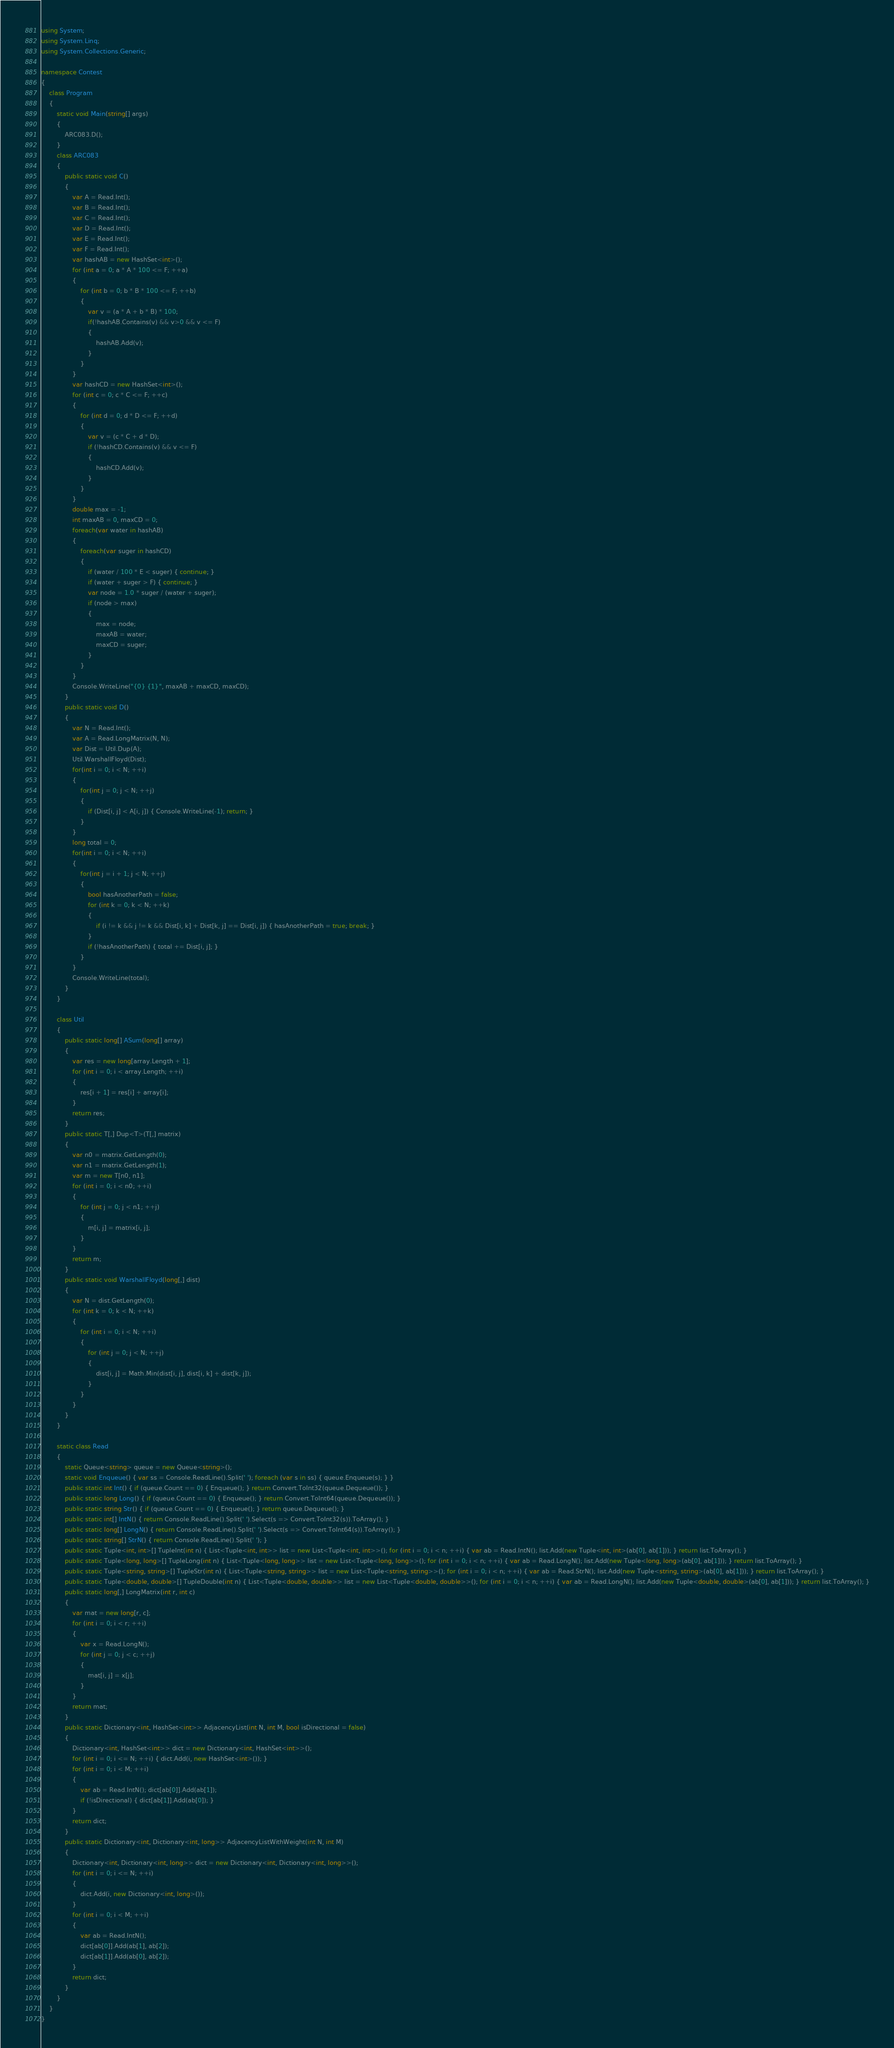Convert code to text. <code><loc_0><loc_0><loc_500><loc_500><_C#_>using System;
using System.Linq;
using System.Collections.Generic;

namespace Contest
{
    class Program
    {
        static void Main(string[] args)
        {
            ARC083.D();
        }
        class ARC083
        {
            public static void C()
            {
                var A = Read.Int();
                var B = Read.Int();
                var C = Read.Int();
                var D = Read.Int();
                var E = Read.Int();
                var F = Read.Int();
                var hashAB = new HashSet<int>();
                for (int a = 0; a * A * 100 <= F; ++a)
                {
                    for (int b = 0; b * B * 100 <= F; ++b)
                    {
                        var v = (a * A + b * B) * 100;
                        if(!hashAB.Contains(v) && v>0 && v <= F)
                        {
                            hashAB.Add(v);
                        }
                    }
                }
                var hashCD = new HashSet<int>();
                for (int c = 0; c * C <= F; ++c)
                {
                    for (int d = 0; d * D <= F; ++d)
                    {
                        var v = (c * C + d * D);
                        if (!hashCD.Contains(v) && v <= F)
                        {
                            hashCD.Add(v);
                        }
                    }
                }
                double max = -1;
                int maxAB = 0, maxCD = 0;
                foreach(var water in hashAB)
                {
                    foreach(var suger in hashCD)
                    {
                        if (water / 100 * E < suger) { continue; }
                        if (water + suger > F) { continue; }
                        var node = 1.0 * suger / (water + suger);
                        if (node > max)
                        {
                            max = node;
                            maxAB = water;
                            maxCD = suger;
                        }
                    }
                }
                Console.WriteLine("{0} {1}", maxAB + maxCD, maxCD);
            }
            public static void D()
            {
                var N = Read.Int();
                var A = Read.LongMatrix(N, N);
                var Dist = Util.Dup(A);
                Util.WarshallFloyd(Dist);
                for(int i = 0; i < N; ++i)
                {
                    for(int j = 0; j < N; ++j)
                    {
                        if (Dist[i, j] < A[i, j]) { Console.WriteLine(-1); return; }
                    }
                }
                long total = 0;
                for(int i = 0; i < N; ++i)
                {
                    for(int j = i + 1; j < N; ++j)
                    {
                        bool hasAnotherPath = false;
                        for (int k = 0; k < N; ++k)
                        {
                            if (i != k && j != k && Dist[i, k] + Dist[k, j] == Dist[i, j]) { hasAnotherPath = true; break; }
                        }
                        if (!hasAnotherPath) { total += Dist[i, j]; }
                    }
                }
                Console.WriteLine(total);
            }
        }

        class Util
        {
            public static long[] ASum(long[] array)
            {
                var res = new long[array.Length + 1];
                for (int i = 0; i < array.Length; ++i)
                {
                    res[i + 1] = res[i] + array[i];
                }
                return res;
            }
            public static T[,] Dup<T>(T[,] matrix)
            {
                var n0 = matrix.GetLength(0);
                var n1 = matrix.GetLength(1);
                var m = new T[n0, n1];
                for (int i = 0; i < n0; ++i)
                {
                    for (int j = 0; j < n1; ++j)
                    {
                        m[i, j] = matrix[i, j];
                    }
                }
                return m;
            }
            public static void WarshallFloyd(long[,] dist)
            {
                var N = dist.GetLength(0);
                for (int k = 0; k < N; ++k)
                {
                    for (int i = 0; i < N; ++i)
                    {
                        for (int j = 0; j < N; ++j)
                        {
                            dist[i, j] = Math.Min(dist[i, j], dist[i, k] + dist[k, j]);
                        }
                    }
                }
            }
        }

        static class Read
        {
            static Queue<string> queue = new Queue<string>();
            static void Enqueue() { var ss = Console.ReadLine().Split(' '); foreach (var s in ss) { queue.Enqueue(s); } }
            public static int Int() { if (queue.Count == 0) { Enqueue(); } return Convert.ToInt32(queue.Dequeue()); }
            public static long Long() { if (queue.Count == 0) { Enqueue(); } return Convert.ToInt64(queue.Dequeue()); }
            public static string Str() { if (queue.Count == 0) { Enqueue(); } return queue.Dequeue(); }
            public static int[] IntN() { return Console.ReadLine().Split(' ').Select(s => Convert.ToInt32(s)).ToArray(); }
            public static long[] LongN() { return Console.ReadLine().Split(' ').Select(s => Convert.ToInt64(s)).ToArray(); }
            public static string[] StrN() { return Console.ReadLine().Split(' '); }
            public static Tuple<int, int>[] TupleInt(int n) { List<Tuple<int, int>> list = new List<Tuple<int, int>>(); for (int i = 0; i < n; ++i) { var ab = Read.IntN(); list.Add(new Tuple<int, int>(ab[0], ab[1])); } return list.ToArray(); }
            public static Tuple<long, long>[] TupleLong(int n) { List<Tuple<long, long>> list = new List<Tuple<long, long>>(); for (int i = 0; i < n; ++i) { var ab = Read.LongN(); list.Add(new Tuple<long, long>(ab[0], ab[1])); } return list.ToArray(); }
            public static Tuple<string, string>[] TupleStr(int n) { List<Tuple<string, string>> list = new List<Tuple<string, string>>(); for (int i = 0; i < n; ++i) { var ab = Read.StrN(); list.Add(new Tuple<string, string>(ab[0], ab[1])); } return list.ToArray(); }
            public static Tuple<double, double>[] TupleDouble(int n) { List<Tuple<double, double>> list = new List<Tuple<double, double>>(); for (int i = 0; i < n; ++i) { var ab = Read.LongN(); list.Add(new Tuple<double, double>(ab[0], ab[1])); } return list.ToArray(); }
            public static long[,] LongMatrix(int r, int c)
            {
                var mat = new long[r, c];
                for (int i = 0; i < r; ++i)
                {
                    var x = Read.LongN();
                    for (int j = 0; j < c; ++j)
                    {
                        mat[i, j] = x[j];
                    }
                }
                return mat;
            }
            public static Dictionary<int, HashSet<int>> AdjacencyList(int N, int M, bool isDirectional = false)
            {
                Dictionary<int, HashSet<int>> dict = new Dictionary<int, HashSet<int>>();
                for (int i = 0; i <= N; ++i) { dict.Add(i, new HashSet<int>()); }
                for (int i = 0; i < M; ++i)
                {
                    var ab = Read.IntN(); dict[ab[0]].Add(ab[1]);
                    if (!isDirectional) { dict[ab[1]].Add(ab[0]); }
                }
                return dict;
            }
            public static Dictionary<int, Dictionary<int, long>> AdjacencyListWithWeight(int N, int M)
            {
                Dictionary<int, Dictionary<int, long>> dict = new Dictionary<int, Dictionary<int, long>>();
                for (int i = 0; i <= N; ++i)
                {
                    dict.Add(i, new Dictionary<int, long>());
                }
                for (int i = 0; i < M; ++i)
                {
                    var ab = Read.IntN();
                    dict[ab[0]].Add(ab[1], ab[2]);
                    dict[ab[1]].Add(ab[0], ab[2]);
                }
                return dict;
            }
        }
    }
}
</code> 